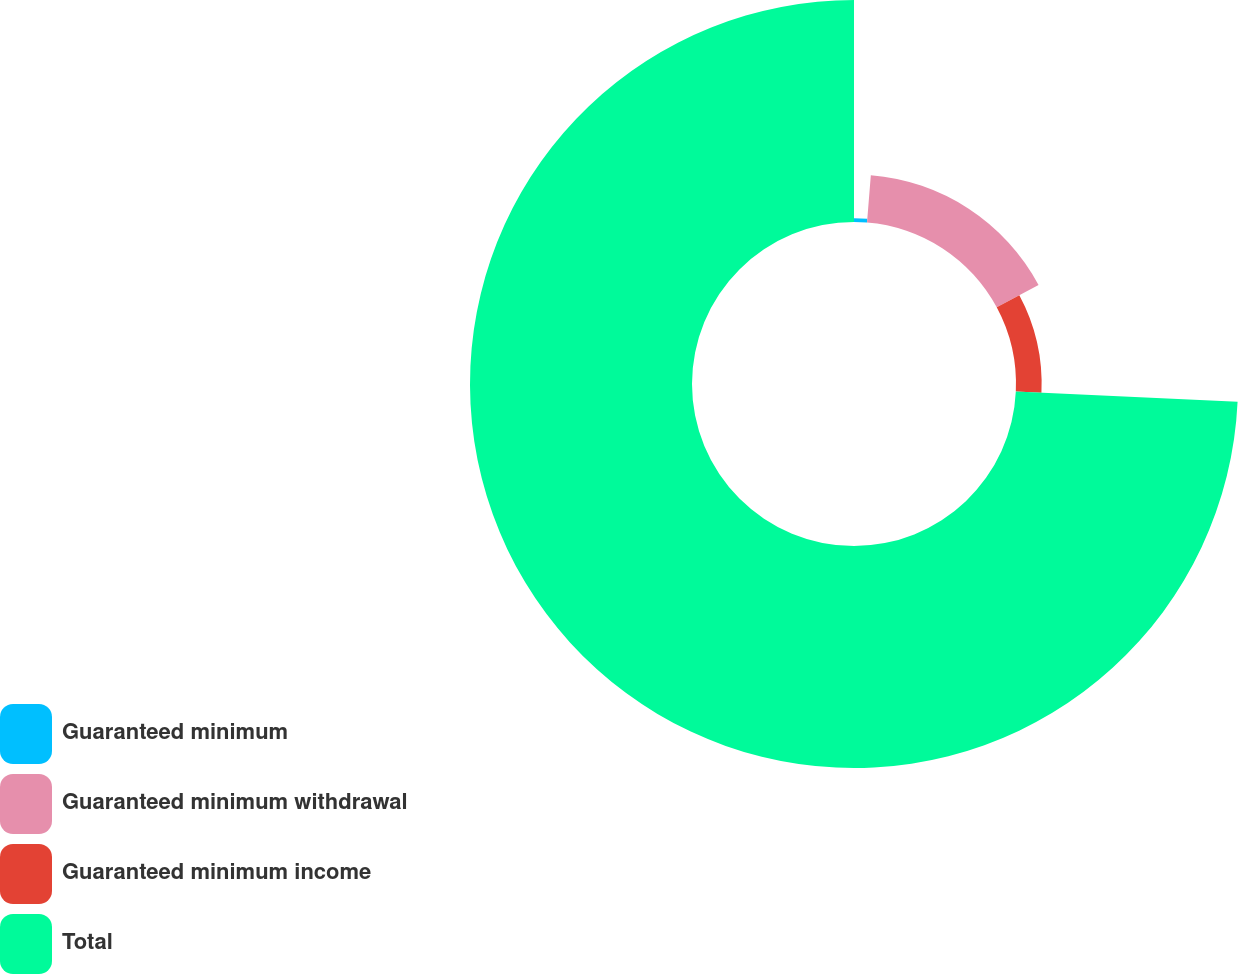Convert chart. <chart><loc_0><loc_0><loc_500><loc_500><pie_chart><fcel>Guaranteed minimum<fcel>Guaranteed minimum withdrawal<fcel>Guaranteed minimum income<fcel>Total<nl><fcel>1.28%<fcel>15.88%<fcel>8.58%<fcel>74.27%<nl></chart> 